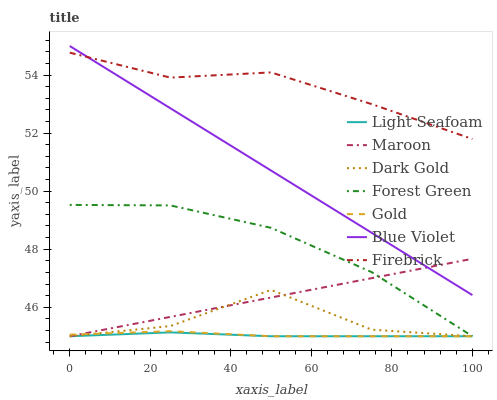Does Light Seafoam have the minimum area under the curve?
Answer yes or no. Yes. Does Firebrick have the maximum area under the curve?
Answer yes or no. Yes. Does Dark Gold have the minimum area under the curve?
Answer yes or no. No. Does Dark Gold have the maximum area under the curve?
Answer yes or no. No. Is Maroon the smoothest?
Answer yes or no. Yes. Is Dark Gold the roughest?
Answer yes or no. Yes. Is Firebrick the smoothest?
Answer yes or no. No. Is Firebrick the roughest?
Answer yes or no. No. Does Gold have the lowest value?
Answer yes or no. Yes. Does Firebrick have the lowest value?
Answer yes or no. No. Does Blue Violet have the highest value?
Answer yes or no. Yes. Does Dark Gold have the highest value?
Answer yes or no. No. Is Dark Gold less than Blue Violet?
Answer yes or no. Yes. Is Blue Violet greater than Gold?
Answer yes or no. Yes. Does Forest Green intersect Gold?
Answer yes or no. Yes. Is Forest Green less than Gold?
Answer yes or no. No. Is Forest Green greater than Gold?
Answer yes or no. No. Does Dark Gold intersect Blue Violet?
Answer yes or no. No. 